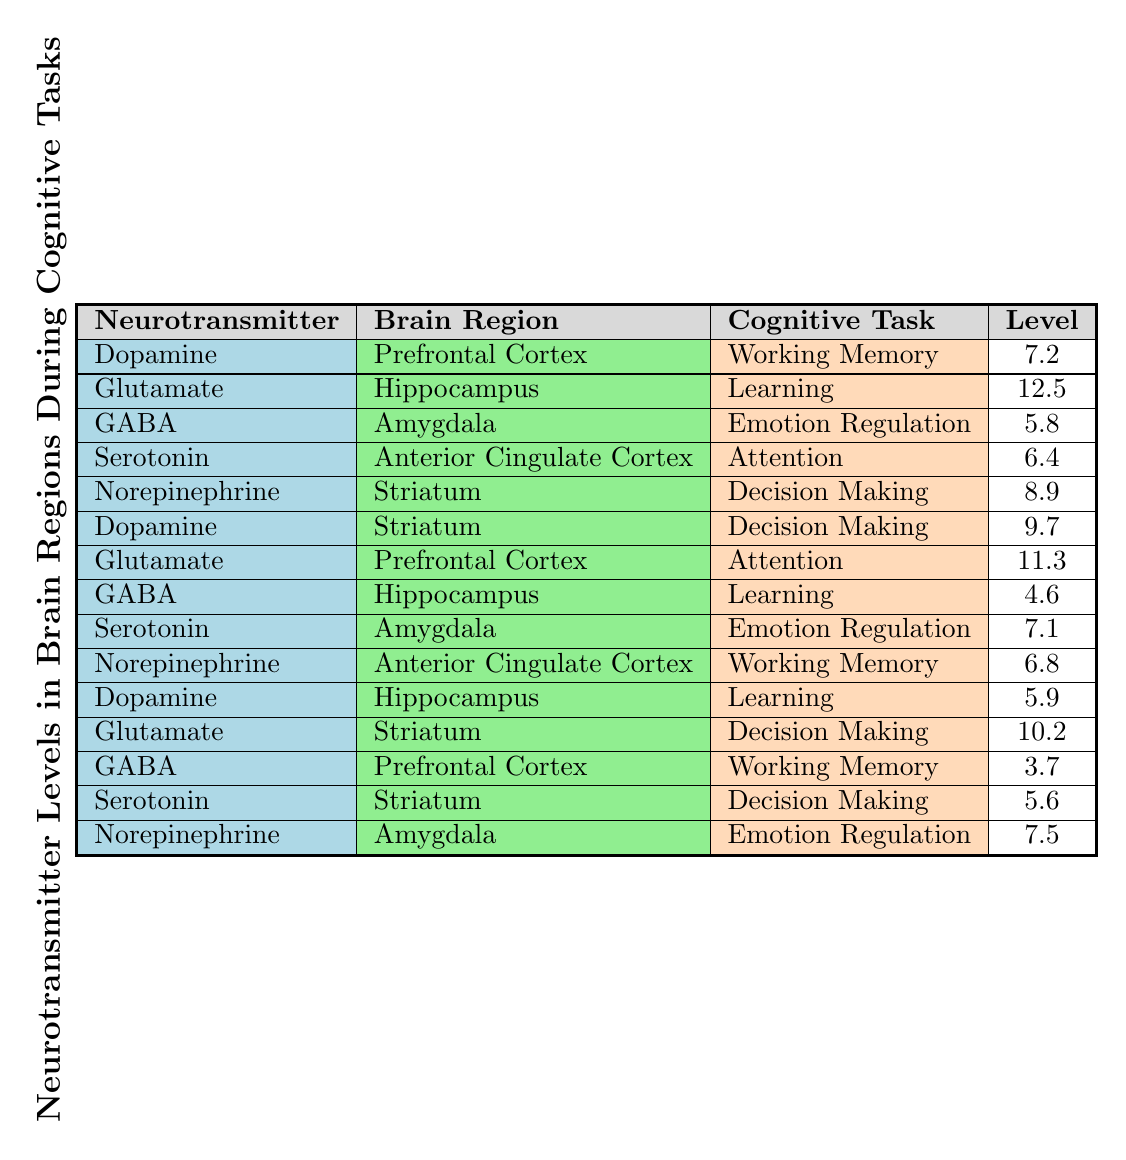What neurotransmitter level is associated with Emotion Regulation in the Amygdala? The table indicates that the neurotransmitter GABA has a level of 5.8 during the Emotion Regulation task in the Amygdala.
Answer: 5.8 Which neurotransmitter has the highest level during the Learning task and in which brain region? Looking at the table, the highest level of neurotransmitter during the Learning task is Glutamate at 12.5 in the Hippocampus.
Answer: Glutamate in the Hippocampus What is the average level of Norepinephrine across all tasks listed? To find the average, we sum the levels of Norepinephrine from each task (6.8 + 7.5 + 8.9) = 23.2. There are 3 levels to average, so 23.2/3 = 7.73.
Answer: 7.73 Is Serotonin involved in the Decision Making task? The table shows that Serotonin has a level of 5.6 during the Decision Making task in the Striatum, confirming its involvement in this task.
Answer: Yes Which cognitive task has the highest recorded level of Glutamate, and what is that level? By reviewing the entries, the Attention task has a Glutamate level of 11.3, which is higher than the 12.5 level in Learning task for a different neurotransmitter.
Answer: Attention task with a level of 11.3 How does the GABA level in the Prefrontal Cortex during Working Memory compare to the GABA level in Hippocampus during Learning? The GABA level during Working Memory in the Prefrontal Cortex is 3.7, while in Hippocampus during Learning it is 4.6. 4.6 is higher than 3.7.
Answer: GABA in Hippocampus is higher What is the difference in Dopamine levels between Working Memory in the Prefrontal Cortex and Decision Making in the Striatum? The Dopamine level in Working Memory is 7.2, and in Decision Making it is 9.7. The difference is calculated as 9.7 - 7.2 = 2.5.
Answer: 2.5 Which brain region shows the most variation in levels across different tasks, and how many unique tasks does it involve? To assess variation, we look at the levels listed for each brain region: the Striatum shows levels for Decision Making and the two are different (9.7 and 10.2), while the Hippocampus has Learning (5.9, 12.5, 4.6), totaling 3 unique tasks (Learning, Emotion Regulation). Hence, the Hippocampus seems like it varies the most with 3 tasks.
Answer: Hippocampus with 3 unique tasks 